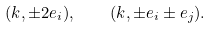Convert formula to latex. <formula><loc_0><loc_0><loc_500><loc_500>( k , \pm 2 e _ { i } ) , \quad ( k , \pm e _ { i } \pm e _ { j } ) .</formula> 